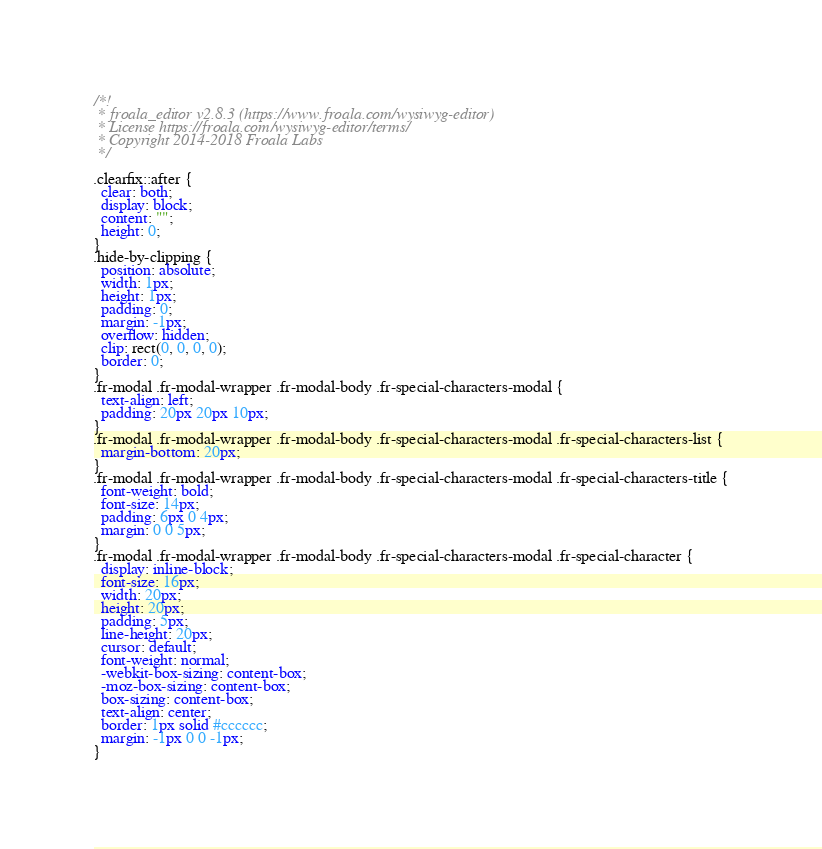Convert code to text. <code><loc_0><loc_0><loc_500><loc_500><_CSS_>/*!
 * froala_editor v2.8.3 (https://www.froala.com/wysiwyg-editor)
 * License https://froala.com/wysiwyg-editor/terms/
 * Copyright 2014-2018 Froala Labs
 */

.clearfix::after {
  clear: both;
  display: block;
  content: "";
  height: 0;
}
.hide-by-clipping {
  position: absolute;
  width: 1px;
  height: 1px;
  padding: 0;
  margin: -1px;
  overflow: hidden;
  clip: rect(0, 0, 0, 0);
  border: 0;
}
.fr-modal .fr-modal-wrapper .fr-modal-body .fr-special-characters-modal {
  text-align: left;
  padding: 20px 20px 10px;
}
.fr-modal .fr-modal-wrapper .fr-modal-body .fr-special-characters-modal .fr-special-characters-list {
  margin-bottom: 20px;
}
.fr-modal .fr-modal-wrapper .fr-modal-body .fr-special-characters-modal .fr-special-characters-title {
  font-weight: bold;
  font-size: 14px;
  padding: 6px 0 4px;
  margin: 0 0 5px;
}
.fr-modal .fr-modal-wrapper .fr-modal-body .fr-special-characters-modal .fr-special-character {
  display: inline-block;
  font-size: 16px;
  width: 20px;
  height: 20px;
  padding: 5px;
  line-height: 20px;
  cursor: default;
  font-weight: normal;
  -webkit-box-sizing: content-box;
  -moz-box-sizing: content-box;
  box-sizing: content-box;
  text-align: center;
  border: 1px solid #cccccc;
  margin: -1px 0 0 -1px;
}
</code> 